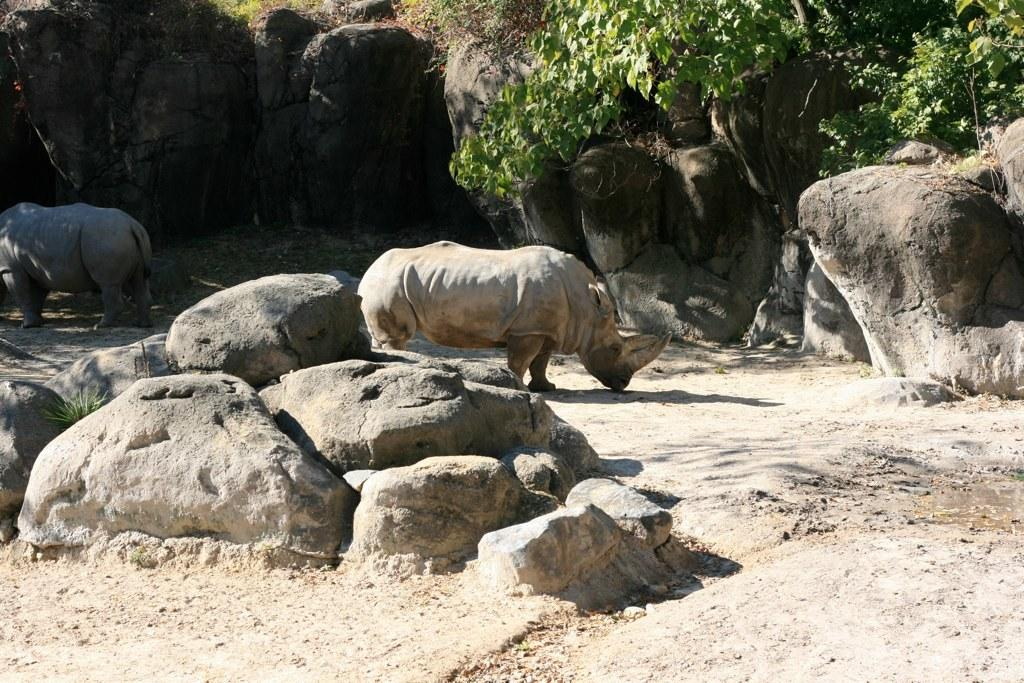How many animals are present in the image? There are two animals in the image. Where are the animals located? The animals are on the ground in the image. What type of natural features can be seen in the image? There are rocks, trees, and grass visible in the image. Can you determine the time of day the image was taken? The image was likely taken during the day, as there is sufficient light to see the details. What song is the animal on the left singing in the image? There is no indication that the animals are singing or making any sounds in the image. 